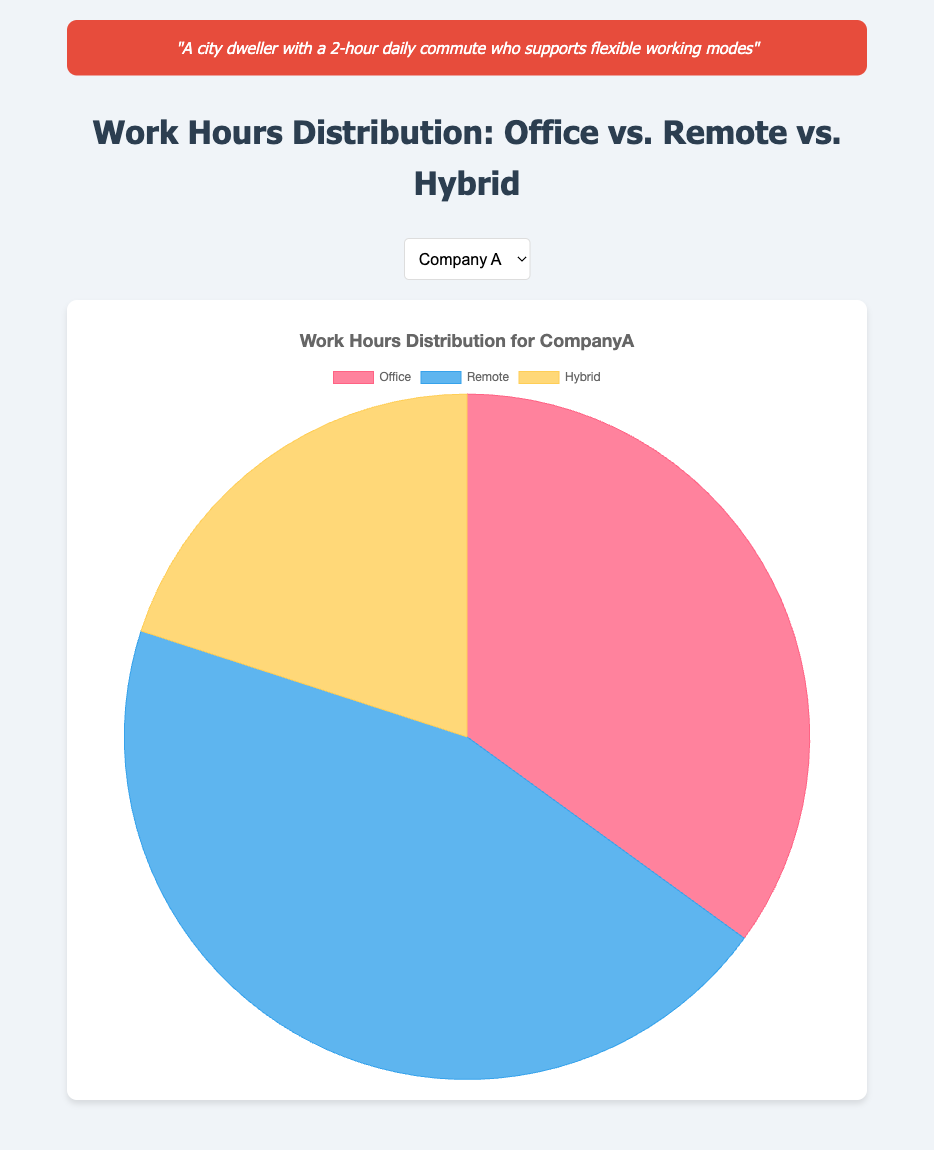What proportion of work hours is spent in the office at Company A? According to the figure, the pie chart segment labeled "Office" for Company A represents 35% of the total work hours.
Answer: 35% Which company has the highest proportion of remote work hours? To determine this, compare the "Remote" segments for all the companies. Company A has 45%, Company B has 30%, and Company C has 50%. Thus, Company C has the highest proportion.
Answer: Company C What is the total proportion of flexible working modes (Remote + Hybrid) for Company B? For Company B, the proportion of Remote work is 30% and the proportion of Hybrid work is 30%. Summing these values gives 30% + 30% = 60%.
Answer: 60% How does the proportion of hybrid work hours at Company C compare with that at Company B? The proportion of Hybrid work hours for Company B is 30%, while for Company C it is 25%. Thus, Company B has a higher proportion of hybrid work hours than Company C.
Answer: Company B has more Which work mode has the smallest proportion of hours for Company A? Looking at the proportions for Company A: Office = 35%, Remote = 45%, Hybrid = 20%. The smallest proportion is Hybrid at 20%.
Answer: Hybrid What is the combined proportion of office work hours across all three companies? Summing the office work proportions for Company A (35%), Company B (40%), and Company C (25%) gives 35% + 40% + 25% = 100%.
Answer: 100% What is the difference in the proportion of remote work between Company A and Company B? Company A has 45% of work hours remote, while Company B has 30%. The difference is 45% - 30% = 15%.
Answer: 15% If you prefer hybrid working modes, which company would be the least favorable? The company with the smallest proportion of hybrid work hours should be the least favorable. Company A has 20%, Company B has 30%, and Company C has 25%. Therefore, Company A would be the least favorable.
Answer: Company A How does the hybrid work proportion for Company A compare to the combined remote and hybrid work proportion for Company C? Company A's hybrid work proportion is 20%. For Company C, summing the remote (50%) and hybrid (25%) work proportions gives 50% + 25% = 75%. Company A's hybrid proportion is much smaller.
Answer: Much smaller What is the mean proportion of remote work hours across the companies? Calculating the mean involves summing the remote proportions (45% for Company A, 30% for Company B, 50% for Company C) and dividing by 3. (45% + 30% + 50%) / 3 = 41.67%.
Answer: 41.67% 